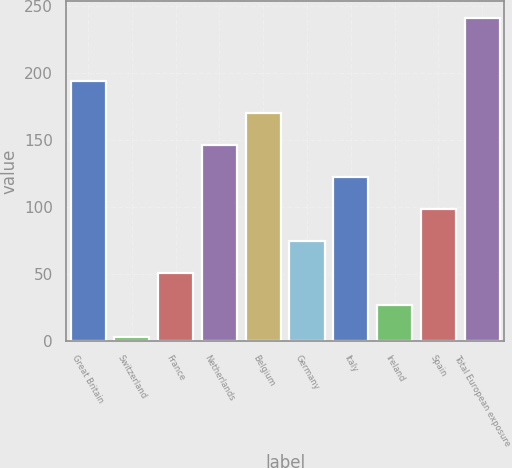Convert chart. <chart><loc_0><loc_0><loc_500><loc_500><bar_chart><fcel>Great Britain<fcel>Switzerland<fcel>France<fcel>Netherlands<fcel>Belgium<fcel>Germany<fcel>Italy<fcel>Ireland<fcel>Spain<fcel>Total European exposure<nl><fcel>193.4<fcel>3<fcel>50.6<fcel>145.8<fcel>169.6<fcel>74.4<fcel>122<fcel>26.8<fcel>98.2<fcel>241<nl></chart> 